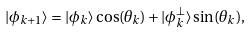Convert formula to latex. <formula><loc_0><loc_0><loc_500><loc_500>| \phi _ { k + 1 } \rangle = | \phi _ { k } \rangle \cos ( \theta _ { k } ) + | \phi _ { k } ^ { \perp } \rangle \sin ( \theta _ { k } ) ,</formula> 